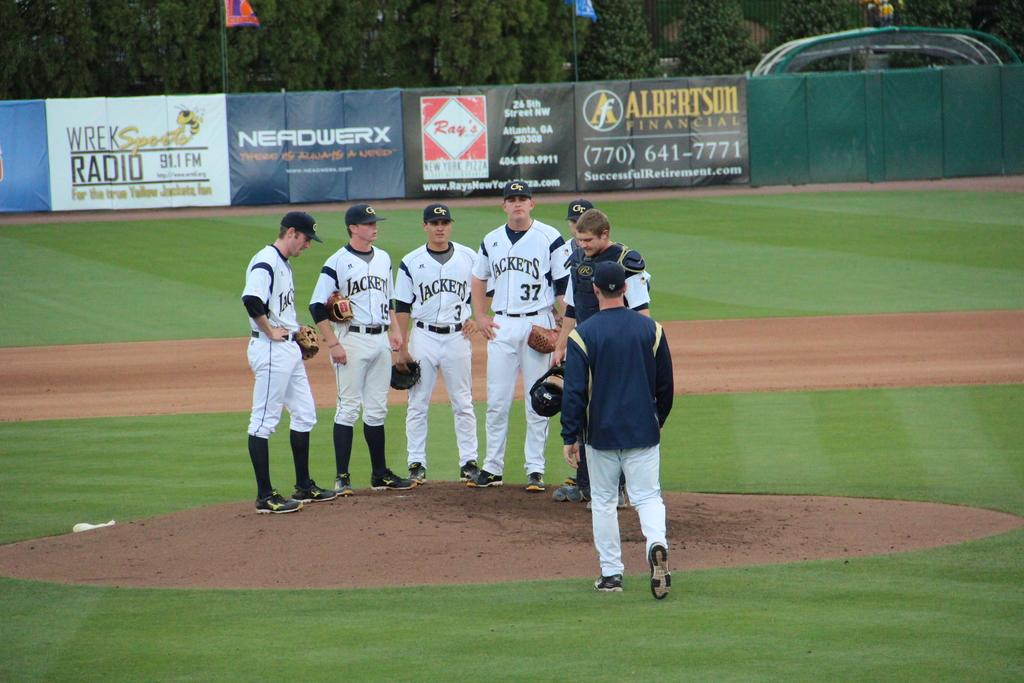Provide a one-sentence caption for the provided image. Players for the Georgia Tech Yellowjackets have a meeting on the pitcher's mound. 